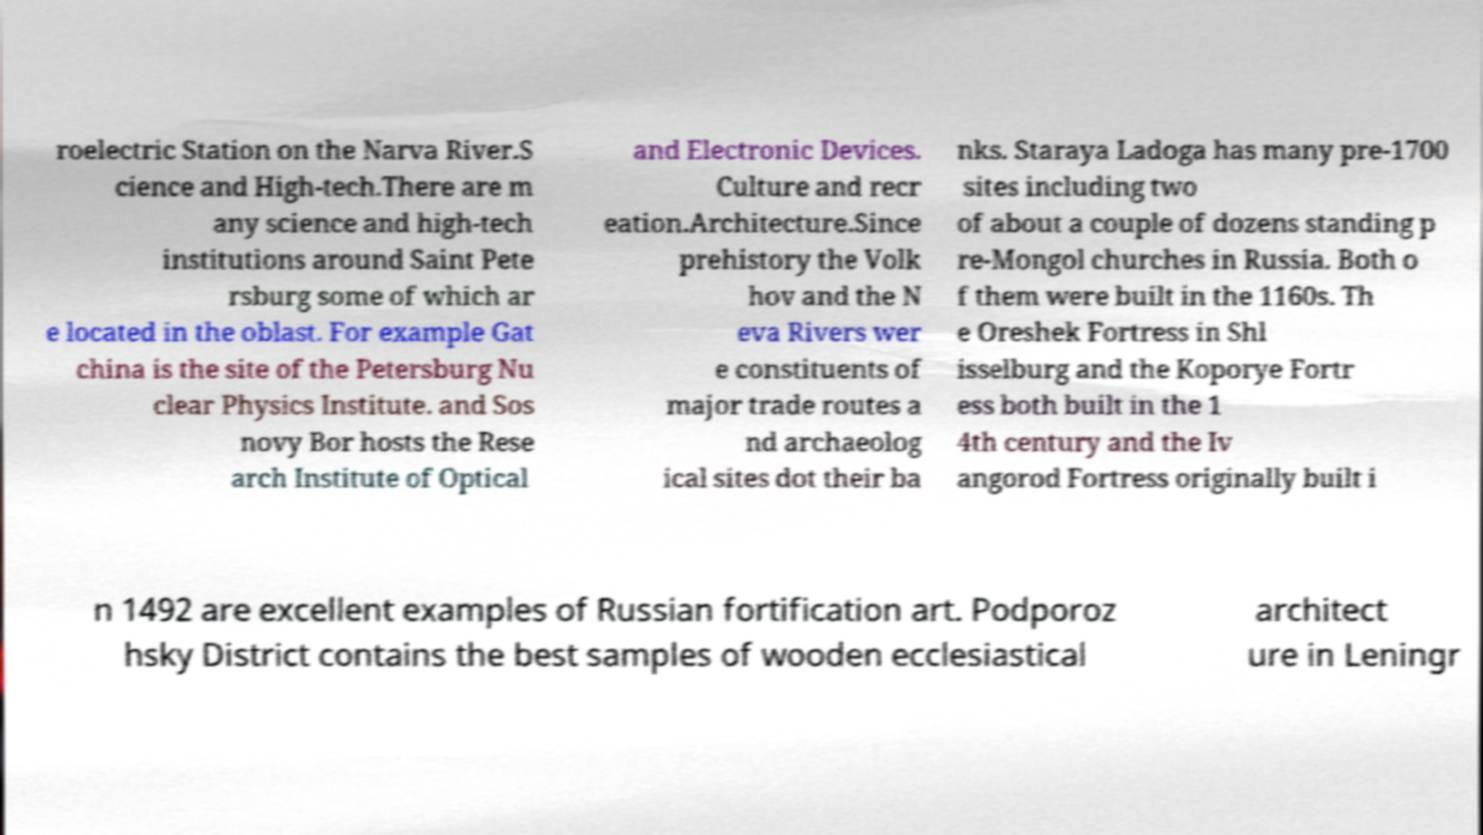I need the written content from this picture converted into text. Can you do that? roelectric Station on the Narva River.S cience and High-tech.There are m any science and high-tech institutions around Saint Pete rsburg some of which ar e located in the oblast. For example Gat china is the site of the Petersburg Nu clear Physics Institute. and Sos novy Bor hosts the Rese arch Institute of Optical and Electronic Devices. Culture and recr eation.Architecture.Since prehistory the Volk hov and the N eva Rivers wer e constituents of major trade routes a nd archaeolog ical sites dot their ba nks. Staraya Ladoga has many pre-1700 sites including two of about a couple of dozens standing p re-Mongol churches in Russia. Both o f them were built in the 1160s. Th e Oreshek Fortress in Shl isselburg and the Koporye Fortr ess both built in the 1 4th century and the Iv angorod Fortress originally built i n 1492 are excellent examples of Russian fortification art. Podporoz hsky District contains the best samples of wooden ecclesiastical architect ure in Leningr 